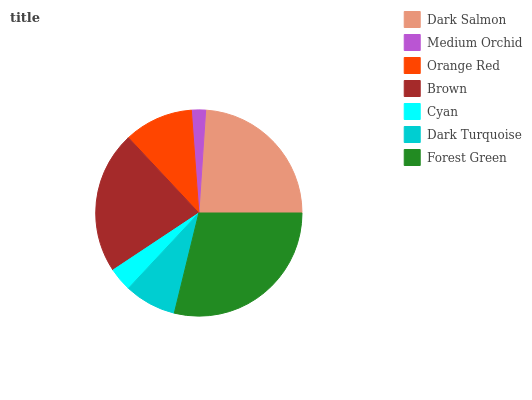Is Medium Orchid the minimum?
Answer yes or no. Yes. Is Forest Green the maximum?
Answer yes or no. Yes. Is Orange Red the minimum?
Answer yes or no. No. Is Orange Red the maximum?
Answer yes or no. No. Is Orange Red greater than Medium Orchid?
Answer yes or no. Yes. Is Medium Orchid less than Orange Red?
Answer yes or no. Yes. Is Medium Orchid greater than Orange Red?
Answer yes or no. No. Is Orange Red less than Medium Orchid?
Answer yes or no. No. Is Orange Red the high median?
Answer yes or no. Yes. Is Orange Red the low median?
Answer yes or no. Yes. Is Brown the high median?
Answer yes or no. No. Is Dark Turquoise the low median?
Answer yes or no. No. 